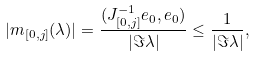Convert formula to latex. <formula><loc_0><loc_0><loc_500><loc_500>| m _ { [ 0 , j ] } ( \lambda ) | = \frac { ( J ^ { - 1 } _ { [ 0 , j ] } e _ { 0 } , e _ { 0 } ) } { | \Im \lambda | } \leq \frac { 1 } { | \Im \lambda | } ,</formula> 